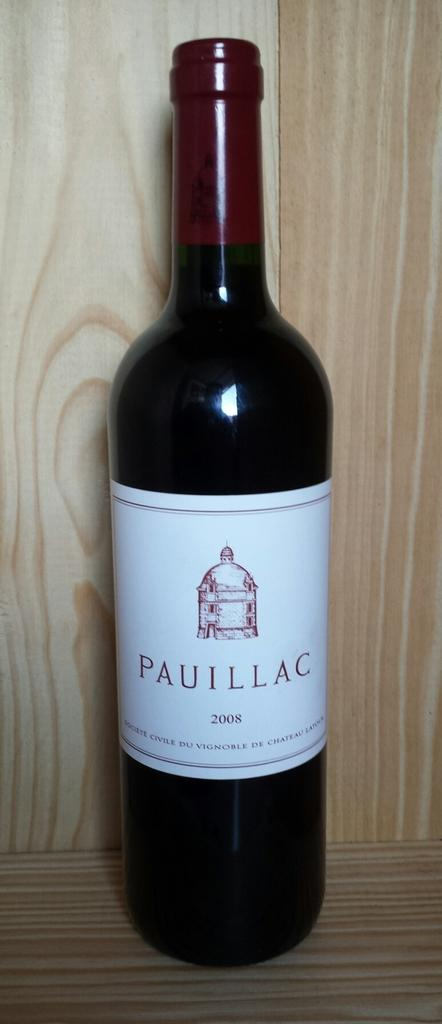<image>
Describe the image concisely. Bottle of wine the brand is Paullac which is not opened 